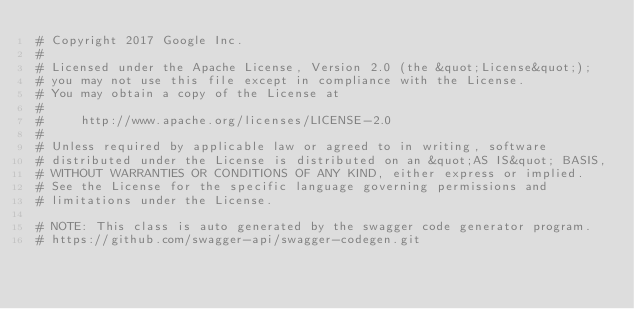Convert code to text. <code><loc_0><loc_0><loc_500><loc_500><_Elixir_># Copyright 2017 Google Inc.
#
# Licensed under the Apache License, Version 2.0 (the &quot;License&quot;);
# you may not use this file except in compliance with the License.
# You may obtain a copy of the License at
#
#     http://www.apache.org/licenses/LICENSE-2.0
#
# Unless required by applicable law or agreed to in writing, software
# distributed under the License is distributed on an &quot;AS IS&quot; BASIS,
# WITHOUT WARRANTIES OR CONDITIONS OF ANY KIND, either express or implied.
# See the License for the specific language governing permissions and
# limitations under the License.

# NOTE: This class is auto generated by the swagger code generator program.
# https://github.com/swagger-api/swagger-codegen.git</code> 